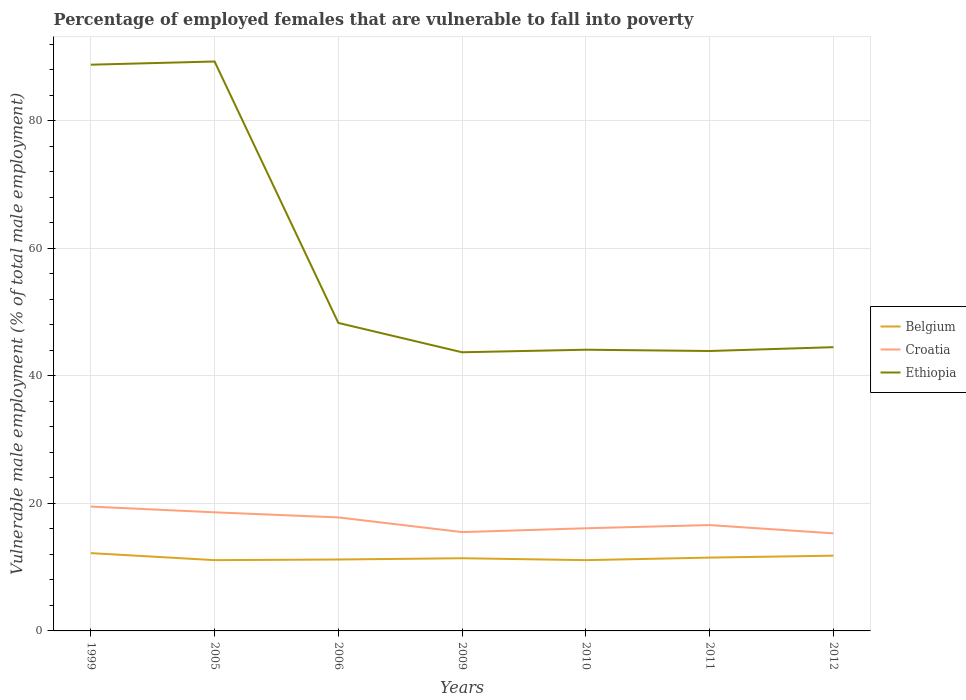Does the line corresponding to Croatia intersect with the line corresponding to Belgium?
Make the answer very short. No. Across all years, what is the maximum percentage of employed females who are vulnerable to fall into poverty in Belgium?
Your response must be concise. 11.1. What is the total percentage of employed females who are vulnerable to fall into poverty in Ethiopia in the graph?
Ensure brevity in your answer.  44.9. What is the difference between the highest and the second highest percentage of employed females who are vulnerable to fall into poverty in Ethiopia?
Offer a terse response. 45.6. What is the difference between the highest and the lowest percentage of employed females who are vulnerable to fall into poverty in Croatia?
Offer a terse response. 3. Where does the legend appear in the graph?
Ensure brevity in your answer.  Center right. How are the legend labels stacked?
Provide a short and direct response. Vertical. What is the title of the graph?
Offer a very short reply. Percentage of employed females that are vulnerable to fall into poverty. What is the label or title of the Y-axis?
Keep it short and to the point. Vulnerable male employment (% of total male employment). What is the Vulnerable male employment (% of total male employment) in Belgium in 1999?
Provide a short and direct response. 12.2. What is the Vulnerable male employment (% of total male employment) of Croatia in 1999?
Your response must be concise. 19.5. What is the Vulnerable male employment (% of total male employment) in Ethiopia in 1999?
Your answer should be very brief. 88.8. What is the Vulnerable male employment (% of total male employment) in Belgium in 2005?
Offer a very short reply. 11.1. What is the Vulnerable male employment (% of total male employment) in Croatia in 2005?
Make the answer very short. 18.6. What is the Vulnerable male employment (% of total male employment) of Ethiopia in 2005?
Keep it short and to the point. 89.3. What is the Vulnerable male employment (% of total male employment) in Belgium in 2006?
Your response must be concise. 11.2. What is the Vulnerable male employment (% of total male employment) of Croatia in 2006?
Ensure brevity in your answer.  17.8. What is the Vulnerable male employment (% of total male employment) in Ethiopia in 2006?
Give a very brief answer. 48.3. What is the Vulnerable male employment (% of total male employment) of Belgium in 2009?
Your answer should be compact. 11.4. What is the Vulnerable male employment (% of total male employment) in Ethiopia in 2009?
Provide a succinct answer. 43.7. What is the Vulnerable male employment (% of total male employment) in Belgium in 2010?
Offer a terse response. 11.1. What is the Vulnerable male employment (% of total male employment) of Croatia in 2010?
Ensure brevity in your answer.  16.1. What is the Vulnerable male employment (% of total male employment) of Ethiopia in 2010?
Ensure brevity in your answer.  44.1. What is the Vulnerable male employment (% of total male employment) of Belgium in 2011?
Make the answer very short. 11.5. What is the Vulnerable male employment (% of total male employment) of Croatia in 2011?
Keep it short and to the point. 16.6. What is the Vulnerable male employment (% of total male employment) of Ethiopia in 2011?
Offer a terse response. 43.9. What is the Vulnerable male employment (% of total male employment) of Belgium in 2012?
Your response must be concise. 11.8. What is the Vulnerable male employment (% of total male employment) in Croatia in 2012?
Offer a terse response. 15.3. What is the Vulnerable male employment (% of total male employment) of Ethiopia in 2012?
Your answer should be compact. 44.5. Across all years, what is the maximum Vulnerable male employment (% of total male employment) of Belgium?
Your answer should be compact. 12.2. Across all years, what is the maximum Vulnerable male employment (% of total male employment) of Ethiopia?
Provide a short and direct response. 89.3. Across all years, what is the minimum Vulnerable male employment (% of total male employment) of Belgium?
Provide a succinct answer. 11.1. Across all years, what is the minimum Vulnerable male employment (% of total male employment) of Croatia?
Your answer should be very brief. 15.3. Across all years, what is the minimum Vulnerable male employment (% of total male employment) of Ethiopia?
Make the answer very short. 43.7. What is the total Vulnerable male employment (% of total male employment) in Belgium in the graph?
Your answer should be compact. 80.3. What is the total Vulnerable male employment (% of total male employment) in Croatia in the graph?
Offer a terse response. 119.4. What is the total Vulnerable male employment (% of total male employment) in Ethiopia in the graph?
Keep it short and to the point. 402.6. What is the difference between the Vulnerable male employment (% of total male employment) of Belgium in 1999 and that in 2005?
Your answer should be compact. 1.1. What is the difference between the Vulnerable male employment (% of total male employment) in Croatia in 1999 and that in 2005?
Provide a succinct answer. 0.9. What is the difference between the Vulnerable male employment (% of total male employment) in Ethiopia in 1999 and that in 2005?
Keep it short and to the point. -0.5. What is the difference between the Vulnerable male employment (% of total male employment) in Belgium in 1999 and that in 2006?
Provide a succinct answer. 1. What is the difference between the Vulnerable male employment (% of total male employment) of Croatia in 1999 and that in 2006?
Offer a very short reply. 1.7. What is the difference between the Vulnerable male employment (% of total male employment) in Ethiopia in 1999 and that in 2006?
Provide a short and direct response. 40.5. What is the difference between the Vulnerable male employment (% of total male employment) of Belgium in 1999 and that in 2009?
Provide a short and direct response. 0.8. What is the difference between the Vulnerable male employment (% of total male employment) in Ethiopia in 1999 and that in 2009?
Offer a very short reply. 45.1. What is the difference between the Vulnerable male employment (% of total male employment) of Ethiopia in 1999 and that in 2010?
Give a very brief answer. 44.7. What is the difference between the Vulnerable male employment (% of total male employment) in Ethiopia in 1999 and that in 2011?
Provide a short and direct response. 44.9. What is the difference between the Vulnerable male employment (% of total male employment) of Belgium in 1999 and that in 2012?
Ensure brevity in your answer.  0.4. What is the difference between the Vulnerable male employment (% of total male employment) of Croatia in 1999 and that in 2012?
Offer a terse response. 4.2. What is the difference between the Vulnerable male employment (% of total male employment) in Ethiopia in 1999 and that in 2012?
Offer a terse response. 44.3. What is the difference between the Vulnerable male employment (% of total male employment) of Ethiopia in 2005 and that in 2009?
Offer a terse response. 45.6. What is the difference between the Vulnerable male employment (% of total male employment) of Belgium in 2005 and that in 2010?
Make the answer very short. 0. What is the difference between the Vulnerable male employment (% of total male employment) in Croatia in 2005 and that in 2010?
Provide a succinct answer. 2.5. What is the difference between the Vulnerable male employment (% of total male employment) of Ethiopia in 2005 and that in 2010?
Your answer should be compact. 45.2. What is the difference between the Vulnerable male employment (% of total male employment) of Belgium in 2005 and that in 2011?
Make the answer very short. -0.4. What is the difference between the Vulnerable male employment (% of total male employment) in Croatia in 2005 and that in 2011?
Provide a succinct answer. 2. What is the difference between the Vulnerable male employment (% of total male employment) of Ethiopia in 2005 and that in 2011?
Provide a succinct answer. 45.4. What is the difference between the Vulnerable male employment (% of total male employment) of Ethiopia in 2005 and that in 2012?
Provide a short and direct response. 44.8. What is the difference between the Vulnerable male employment (% of total male employment) in Ethiopia in 2006 and that in 2009?
Give a very brief answer. 4.6. What is the difference between the Vulnerable male employment (% of total male employment) in Ethiopia in 2006 and that in 2010?
Your response must be concise. 4.2. What is the difference between the Vulnerable male employment (% of total male employment) in Croatia in 2006 and that in 2011?
Provide a short and direct response. 1.2. What is the difference between the Vulnerable male employment (% of total male employment) of Ethiopia in 2006 and that in 2011?
Give a very brief answer. 4.4. What is the difference between the Vulnerable male employment (% of total male employment) in Belgium in 2006 and that in 2012?
Provide a succinct answer. -0.6. What is the difference between the Vulnerable male employment (% of total male employment) of Croatia in 2006 and that in 2012?
Offer a very short reply. 2.5. What is the difference between the Vulnerable male employment (% of total male employment) of Ethiopia in 2009 and that in 2010?
Offer a very short reply. -0.4. What is the difference between the Vulnerable male employment (% of total male employment) in Ethiopia in 2009 and that in 2011?
Keep it short and to the point. -0.2. What is the difference between the Vulnerable male employment (% of total male employment) in Ethiopia in 2009 and that in 2012?
Ensure brevity in your answer.  -0.8. What is the difference between the Vulnerable male employment (% of total male employment) of Belgium in 2010 and that in 2011?
Keep it short and to the point. -0.4. What is the difference between the Vulnerable male employment (% of total male employment) in Croatia in 2010 and that in 2011?
Keep it short and to the point. -0.5. What is the difference between the Vulnerable male employment (% of total male employment) of Belgium in 2010 and that in 2012?
Provide a succinct answer. -0.7. What is the difference between the Vulnerable male employment (% of total male employment) of Croatia in 2010 and that in 2012?
Offer a terse response. 0.8. What is the difference between the Vulnerable male employment (% of total male employment) in Ethiopia in 2010 and that in 2012?
Offer a very short reply. -0.4. What is the difference between the Vulnerable male employment (% of total male employment) in Croatia in 2011 and that in 2012?
Make the answer very short. 1.3. What is the difference between the Vulnerable male employment (% of total male employment) of Belgium in 1999 and the Vulnerable male employment (% of total male employment) of Ethiopia in 2005?
Keep it short and to the point. -77.1. What is the difference between the Vulnerable male employment (% of total male employment) of Croatia in 1999 and the Vulnerable male employment (% of total male employment) of Ethiopia in 2005?
Provide a succinct answer. -69.8. What is the difference between the Vulnerable male employment (% of total male employment) of Belgium in 1999 and the Vulnerable male employment (% of total male employment) of Ethiopia in 2006?
Provide a short and direct response. -36.1. What is the difference between the Vulnerable male employment (% of total male employment) of Croatia in 1999 and the Vulnerable male employment (% of total male employment) of Ethiopia in 2006?
Make the answer very short. -28.8. What is the difference between the Vulnerable male employment (% of total male employment) in Belgium in 1999 and the Vulnerable male employment (% of total male employment) in Croatia in 2009?
Offer a terse response. -3.3. What is the difference between the Vulnerable male employment (% of total male employment) of Belgium in 1999 and the Vulnerable male employment (% of total male employment) of Ethiopia in 2009?
Keep it short and to the point. -31.5. What is the difference between the Vulnerable male employment (% of total male employment) of Croatia in 1999 and the Vulnerable male employment (% of total male employment) of Ethiopia in 2009?
Ensure brevity in your answer.  -24.2. What is the difference between the Vulnerable male employment (% of total male employment) in Belgium in 1999 and the Vulnerable male employment (% of total male employment) in Croatia in 2010?
Your answer should be compact. -3.9. What is the difference between the Vulnerable male employment (% of total male employment) of Belgium in 1999 and the Vulnerable male employment (% of total male employment) of Ethiopia in 2010?
Ensure brevity in your answer.  -31.9. What is the difference between the Vulnerable male employment (% of total male employment) in Croatia in 1999 and the Vulnerable male employment (% of total male employment) in Ethiopia in 2010?
Offer a terse response. -24.6. What is the difference between the Vulnerable male employment (% of total male employment) in Belgium in 1999 and the Vulnerable male employment (% of total male employment) in Croatia in 2011?
Your answer should be compact. -4.4. What is the difference between the Vulnerable male employment (% of total male employment) in Belgium in 1999 and the Vulnerable male employment (% of total male employment) in Ethiopia in 2011?
Give a very brief answer. -31.7. What is the difference between the Vulnerable male employment (% of total male employment) in Croatia in 1999 and the Vulnerable male employment (% of total male employment) in Ethiopia in 2011?
Your response must be concise. -24.4. What is the difference between the Vulnerable male employment (% of total male employment) of Belgium in 1999 and the Vulnerable male employment (% of total male employment) of Ethiopia in 2012?
Give a very brief answer. -32.3. What is the difference between the Vulnerable male employment (% of total male employment) in Belgium in 2005 and the Vulnerable male employment (% of total male employment) in Ethiopia in 2006?
Make the answer very short. -37.2. What is the difference between the Vulnerable male employment (% of total male employment) of Croatia in 2005 and the Vulnerable male employment (% of total male employment) of Ethiopia in 2006?
Give a very brief answer. -29.7. What is the difference between the Vulnerable male employment (% of total male employment) in Belgium in 2005 and the Vulnerable male employment (% of total male employment) in Croatia in 2009?
Offer a very short reply. -4.4. What is the difference between the Vulnerable male employment (% of total male employment) in Belgium in 2005 and the Vulnerable male employment (% of total male employment) in Ethiopia in 2009?
Give a very brief answer. -32.6. What is the difference between the Vulnerable male employment (% of total male employment) of Croatia in 2005 and the Vulnerable male employment (% of total male employment) of Ethiopia in 2009?
Provide a short and direct response. -25.1. What is the difference between the Vulnerable male employment (% of total male employment) of Belgium in 2005 and the Vulnerable male employment (% of total male employment) of Ethiopia in 2010?
Ensure brevity in your answer.  -33. What is the difference between the Vulnerable male employment (% of total male employment) of Croatia in 2005 and the Vulnerable male employment (% of total male employment) of Ethiopia in 2010?
Your answer should be compact. -25.5. What is the difference between the Vulnerable male employment (% of total male employment) of Belgium in 2005 and the Vulnerable male employment (% of total male employment) of Croatia in 2011?
Offer a very short reply. -5.5. What is the difference between the Vulnerable male employment (% of total male employment) of Belgium in 2005 and the Vulnerable male employment (% of total male employment) of Ethiopia in 2011?
Give a very brief answer. -32.8. What is the difference between the Vulnerable male employment (% of total male employment) in Croatia in 2005 and the Vulnerable male employment (% of total male employment) in Ethiopia in 2011?
Provide a succinct answer. -25.3. What is the difference between the Vulnerable male employment (% of total male employment) in Belgium in 2005 and the Vulnerable male employment (% of total male employment) in Ethiopia in 2012?
Your answer should be compact. -33.4. What is the difference between the Vulnerable male employment (% of total male employment) of Croatia in 2005 and the Vulnerable male employment (% of total male employment) of Ethiopia in 2012?
Provide a succinct answer. -25.9. What is the difference between the Vulnerable male employment (% of total male employment) in Belgium in 2006 and the Vulnerable male employment (% of total male employment) in Ethiopia in 2009?
Make the answer very short. -32.5. What is the difference between the Vulnerable male employment (% of total male employment) of Croatia in 2006 and the Vulnerable male employment (% of total male employment) of Ethiopia in 2009?
Keep it short and to the point. -25.9. What is the difference between the Vulnerable male employment (% of total male employment) of Belgium in 2006 and the Vulnerable male employment (% of total male employment) of Ethiopia in 2010?
Your response must be concise. -32.9. What is the difference between the Vulnerable male employment (% of total male employment) in Croatia in 2006 and the Vulnerable male employment (% of total male employment) in Ethiopia in 2010?
Ensure brevity in your answer.  -26.3. What is the difference between the Vulnerable male employment (% of total male employment) in Belgium in 2006 and the Vulnerable male employment (% of total male employment) in Ethiopia in 2011?
Keep it short and to the point. -32.7. What is the difference between the Vulnerable male employment (% of total male employment) in Croatia in 2006 and the Vulnerable male employment (% of total male employment) in Ethiopia in 2011?
Your answer should be very brief. -26.1. What is the difference between the Vulnerable male employment (% of total male employment) in Belgium in 2006 and the Vulnerable male employment (% of total male employment) in Croatia in 2012?
Your response must be concise. -4.1. What is the difference between the Vulnerable male employment (% of total male employment) in Belgium in 2006 and the Vulnerable male employment (% of total male employment) in Ethiopia in 2012?
Provide a succinct answer. -33.3. What is the difference between the Vulnerable male employment (% of total male employment) in Croatia in 2006 and the Vulnerable male employment (% of total male employment) in Ethiopia in 2012?
Make the answer very short. -26.7. What is the difference between the Vulnerable male employment (% of total male employment) of Belgium in 2009 and the Vulnerable male employment (% of total male employment) of Croatia in 2010?
Provide a succinct answer. -4.7. What is the difference between the Vulnerable male employment (% of total male employment) of Belgium in 2009 and the Vulnerable male employment (% of total male employment) of Ethiopia in 2010?
Keep it short and to the point. -32.7. What is the difference between the Vulnerable male employment (% of total male employment) in Croatia in 2009 and the Vulnerable male employment (% of total male employment) in Ethiopia in 2010?
Your answer should be very brief. -28.6. What is the difference between the Vulnerable male employment (% of total male employment) in Belgium in 2009 and the Vulnerable male employment (% of total male employment) in Croatia in 2011?
Make the answer very short. -5.2. What is the difference between the Vulnerable male employment (% of total male employment) of Belgium in 2009 and the Vulnerable male employment (% of total male employment) of Ethiopia in 2011?
Ensure brevity in your answer.  -32.5. What is the difference between the Vulnerable male employment (% of total male employment) in Croatia in 2009 and the Vulnerable male employment (% of total male employment) in Ethiopia in 2011?
Your answer should be very brief. -28.4. What is the difference between the Vulnerable male employment (% of total male employment) of Belgium in 2009 and the Vulnerable male employment (% of total male employment) of Croatia in 2012?
Provide a succinct answer. -3.9. What is the difference between the Vulnerable male employment (% of total male employment) in Belgium in 2009 and the Vulnerable male employment (% of total male employment) in Ethiopia in 2012?
Offer a very short reply. -33.1. What is the difference between the Vulnerable male employment (% of total male employment) in Croatia in 2009 and the Vulnerable male employment (% of total male employment) in Ethiopia in 2012?
Keep it short and to the point. -29. What is the difference between the Vulnerable male employment (% of total male employment) in Belgium in 2010 and the Vulnerable male employment (% of total male employment) in Croatia in 2011?
Keep it short and to the point. -5.5. What is the difference between the Vulnerable male employment (% of total male employment) in Belgium in 2010 and the Vulnerable male employment (% of total male employment) in Ethiopia in 2011?
Keep it short and to the point. -32.8. What is the difference between the Vulnerable male employment (% of total male employment) of Croatia in 2010 and the Vulnerable male employment (% of total male employment) of Ethiopia in 2011?
Offer a very short reply. -27.8. What is the difference between the Vulnerable male employment (% of total male employment) in Belgium in 2010 and the Vulnerable male employment (% of total male employment) in Ethiopia in 2012?
Your answer should be compact. -33.4. What is the difference between the Vulnerable male employment (% of total male employment) in Croatia in 2010 and the Vulnerable male employment (% of total male employment) in Ethiopia in 2012?
Ensure brevity in your answer.  -28.4. What is the difference between the Vulnerable male employment (% of total male employment) in Belgium in 2011 and the Vulnerable male employment (% of total male employment) in Ethiopia in 2012?
Make the answer very short. -33. What is the difference between the Vulnerable male employment (% of total male employment) in Croatia in 2011 and the Vulnerable male employment (% of total male employment) in Ethiopia in 2012?
Keep it short and to the point. -27.9. What is the average Vulnerable male employment (% of total male employment) in Belgium per year?
Offer a terse response. 11.47. What is the average Vulnerable male employment (% of total male employment) in Croatia per year?
Offer a very short reply. 17.06. What is the average Vulnerable male employment (% of total male employment) in Ethiopia per year?
Offer a terse response. 57.51. In the year 1999, what is the difference between the Vulnerable male employment (% of total male employment) of Belgium and Vulnerable male employment (% of total male employment) of Ethiopia?
Ensure brevity in your answer.  -76.6. In the year 1999, what is the difference between the Vulnerable male employment (% of total male employment) of Croatia and Vulnerable male employment (% of total male employment) of Ethiopia?
Offer a terse response. -69.3. In the year 2005, what is the difference between the Vulnerable male employment (% of total male employment) in Belgium and Vulnerable male employment (% of total male employment) in Ethiopia?
Keep it short and to the point. -78.2. In the year 2005, what is the difference between the Vulnerable male employment (% of total male employment) of Croatia and Vulnerable male employment (% of total male employment) of Ethiopia?
Keep it short and to the point. -70.7. In the year 2006, what is the difference between the Vulnerable male employment (% of total male employment) in Belgium and Vulnerable male employment (% of total male employment) in Croatia?
Provide a succinct answer. -6.6. In the year 2006, what is the difference between the Vulnerable male employment (% of total male employment) of Belgium and Vulnerable male employment (% of total male employment) of Ethiopia?
Your answer should be very brief. -37.1. In the year 2006, what is the difference between the Vulnerable male employment (% of total male employment) of Croatia and Vulnerable male employment (% of total male employment) of Ethiopia?
Your response must be concise. -30.5. In the year 2009, what is the difference between the Vulnerable male employment (% of total male employment) of Belgium and Vulnerable male employment (% of total male employment) of Croatia?
Give a very brief answer. -4.1. In the year 2009, what is the difference between the Vulnerable male employment (% of total male employment) of Belgium and Vulnerable male employment (% of total male employment) of Ethiopia?
Give a very brief answer. -32.3. In the year 2009, what is the difference between the Vulnerable male employment (% of total male employment) in Croatia and Vulnerable male employment (% of total male employment) in Ethiopia?
Keep it short and to the point. -28.2. In the year 2010, what is the difference between the Vulnerable male employment (% of total male employment) of Belgium and Vulnerable male employment (% of total male employment) of Ethiopia?
Keep it short and to the point. -33. In the year 2010, what is the difference between the Vulnerable male employment (% of total male employment) of Croatia and Vulnerable male employment (% of total male employment) of Ethiopia?
Your response must be concise. -28. In the year 2011, what is the difference between the Vulnerable male employment (% of total male employment) in Belgium and Vulnerable male employment (% of total male employment) in Ethiopia?
Your response must be concise. -32.4. In the year 2011, what is the difference between the Vulnerable male employment (% of total male employment) in Croatia and Vulnerable male employment (% of total male employment) in Ethiopia?
Ensure brevity in your answer.  -27.3. In the year 2012, what is the difference between the Vulnerable male employment (% of total male employment) of Belgium and Vulnerable male employment (% of total male employment) of Croatia?
Offer a terse response. -3.5. In the year 2012, what is the difference between the Vulnerable male employment (% of total male employment) in Belgium and Vulnerable male employment (% of total male employment) in Ethiopia?
Give a very brief answer. -32.7. In the year 2012, what is the difference between the Vulnerable male employment (% of total male employment) of Croatia and Vulnerable male employment (% of total male employment) of Ethiopia?
Offer a terse response. -29.2. What is the ratio of the Vulnerable male employment (% of total male employment) in Belgium in 1999 to that in 2005?
Your answer should be very brief. 1.1. What is the ratio of the Vulnerable male employment (% of total male employment) in Croatia in 1999 to that in 2005?
Provide a short and direct response. 1.05. What is the ratio of the Vulnerable male employment (% of total male employment) of Belgium in 1999 to that in 2006?
Keep it short and to the point. 1.09. What is the ratio of the Vulnerable male employment (% of total male employment) in Croatia in 1999 to that in 2006?
Your answer should be very brief. 1.1. What is the ratio of the Vulnerable male employment (% of total male employment) in Ethiopia in 1999 to that in 2006?
Your response must be concise. 1.84. What is the ratio of the Vulnerable male employment (% of total male employment) in Belgium in 1999 to that in 2009?
Your response must be concise. 1.07. What is the ratio of the Vulnerable male employment (% of total male employment) in Croatia in 1999 to that in 2009?
Give a very brief answer. 1.26. What is the ratio of the Vulnerable male employment (% of total male employment) in Ethiopia in 1999 to that in 2009?
Ensure brevity in your answer.  2.03. What is the ratio of the Vulnerable male employment (% of total male employment) of Belgium in 1999 to that in 2010?
Make the answer very short. 1.1. What is the ratio of the Vulnerable male employment (% of total male employment) in Croatia in 1999 to that in 2010?
Your response must be concise. 1.21. What is the ratio of the Vulnerable male employment (% of total male employment) of Ethiopia in 1999 to that in 2010?
Your answer should be very brief. 2.01. What is the ratio of the Vulnerable male employment (% of total male employment) in Belgium in 1999 to that in 2011?
Your response must be concise. 1.06. What is the ratio of the Vulnerable male employment (% of total male employment) in Croatia in 1999 to that in 2011?
Offer a very short reply. 1.17. What is the ratio of the Vulnerable male employment (% of total male employment) in Ethiopia in 1999 to that in 2011?
Give a very brief answer. 2.02. What is the ratio of the Vulnerable male employment (% of total male employment) in Belgium in 1999 to that in 2012?
Offer a very short reply. 1.03. What is the ratio of the Vulnerable male employment (% of total male employment) of Croatia in 1999 to that in 2012?
Keep it short and to the point. 1.27. What is the ratio of the Vulnerable male employment (% of total male employment) in Ethiopia in 1999 to that in 2012?
Your answer should be compact. 2. What is the ratio of the Vulnerable male employment (% of total male employment) in Croatia in 2005 to that in 2006?
Keep it short and to the point. 1.04. What is the ratio of the Vulnerable male employment (% of total male employment) in Ethiopia in 2005 to that in 2006?
Make the answer very short. 1.85. What is the ratio of the Vulnerable male employment (% of total male employment) in Belgium in 2005 to that in 2009?
Make the answer very short. 0.97. What is the ratio of the Vulnerable male employment (% of total male employment) in Croatia in 2005 to that in 2009?
Give a very brief answer. 1.2. What is the ratio of the Vulnerable male employment (% of total male employment) in Ethiopia in 2005 to that in 2009?
Keep it short and to the point. 2.04. What is the ratio of the Vulnerable male employment (% of total male employment) in Croatia in 2005 to that in 2010?
Provide a short and direct response. 1.16. What is the ratio of the Vulnerable male employment (% of total male employment) in Ethiopia in 2005 to that in 2010?
Provide a succinct answer. 2.02. What is the ratio of the Vulnerable male employment (% of total male employment) in Belgium in 2005 to that in 2011?
Your answer should be compact. 0.97. What is the ratio of the Vulnerable male employment (% of total male employment) of Croatia in 2005 to that in 2011?
Make the answer very short. 1.12. What is the ratio of the Vulnerable male employment (% of total male employment) in Ethiopia in 2005 to that in 2011?
Provide a succinct answer. 2.03. What is the ratio of the Vulnerable male employment (% of total male employment) of Belgium in 2005 to that in 2012?
Keep it short and to the point. 0.94. What is the ratio of the Vulnerable male employment (% of total male employment) of Croatia in 2005 to that in 2012?
Offer a terse response. 1.22. What is the ratio of the Vulnerable male employment (% of total male employment) of Ethiopia in 2005 to that in 2012?
Make the answer very short. 2.01. What is the ratio of the Vulnerable male employment (% of total male employment) of Belgium in 2006 to that in 2009?
Ensure brevity in your answer.  0.98. What is the ratio of the Vulnerable male employment (% of total male employment) in Croatia in 2006 to that in 2009?
Keep it short and to the point. 1.15. What is the ratio of the Vulnerable male employment (% of total male employment) of Ethiopia in 2006 to that in 2009?
Ensure brevity in your answer.  1.11. What is the ratio of the Vulnerable male employment (% of total male employment) in Croatia in 2006 to that in 2010?
Your answer should be very brief. 1.11. What is the ratio of the Vulnerable male employment (% of total male employment) in Ethiopia in 2006 to that in 2010?
Your answer should be very brief. 1.1. What is the ratio of the Vulnerable male employment (% of total male employment) in Belgium in 2006 to that in 2011?
Ensure brevity in your answer.  0.97. What is the ratio of the Vulnerable male employment (% of total male employment) in Croatia in 2006 to that in 2011?
Your response must be concise. 1.07. What is the ratio of the Vulnerable male employment (% of total male employment) in Ethiopia in 2006 to that in 2011?
Make the answer very short. 1.1. What is the ratio of the Vulnerable male employment (% of total male employment) in Belgium in 2006 to that in 2012?
Ensure brevity in your answer.  0.95. What is the ratio of the Vulnerable male employment (% of total male employment) of Croatia in 2006 to that in 2012?
Offer a terse response. 1.16. What is the ratio of the Vulnerable male employment (% of total male employment) of Ethiopia in 2006 to that in 2012?
Your answer should be compact. 1.09. What is the ratio of the Vulnerable male employment (% of total male employment) of Croatia in 2009 to that in 2010?
Provide a short and direct response. 0.96. What is the ratio of the Vulnerable male employment (% of total male employment) in Ethiopia in 2009 to that in 2010?
Offer a terse response. 0.99. What is the ratio of the Vulnerable male employment (% of total male employment) of Belgium in 2009 to that in 2011?
Offer a very short reply. 0.99. What is the ratio of the Vulnerable male employment (% of total male employment) in Croatia in 2009 to that in 2011?
Your answer should be compact. 0.93. What is the ratio of the Vulnerable male employment (% of total male employment) in Ethiopia in 2009 to that in 2011?
Give a very brief answer. 1. What is the ratio of the Vulnerable male employment (% of total male employment) in Belgium in 2009 to that in 2012?
Give a very brief answer. 0.97. What is the ratio of the Vulnerable male employment (% of total male employment) of Croatia in 2009 to that in 2012?
Keep it short and to the point. 1.01. What is the ratio of the Vulnerable male employment (% of total male employment) of Ethiopia in 2009 to that in 2012?
Your answer should be compact. 0.98. What is the ratio of the Vulnerable male employment (% of total male employment) of Belgium in 2010 to that in 2011?
Provide a succinct answer. 0.97. What is the ratio of the Vulnerable male employment (% of total male employment) of Croatia in 2010 to that in 2011?
Your response must be concise. 0.97. What is the ratio of the Vulnerable male employment (% of total male employment) in Belgium in 2010 to that in 2012?
Your answer should be very brief. 0.94. What is the ratio of the Vulnerable male employment (% of total male employment) in Croatia in 2010 to that in 2012?
Ensure brevity in your answer.  1.05. What is the ratio of the Vulnerable male employment (% of total male employment) of Belgium in 2011 to that in 2012?
Keep it short and to the point. 0.97. What is the ratio of the Vulnerable male employment (% of total male employment) in Croatia in 2011 to that in 2012?
Offer a terse response. 1.08. What is the ratio of the Vulnerable male employment (% of total male employment) of Ethiopia in 2011 to that in 2012?
Your answer should be compact. 0.99. What is the difference between the highest and the second highest Vulnerable male employment (% of total male employment) in Belgium?
Offer a terse response. 0.4. What is the difference between the highest and the lowest Vulnerable male employment (% of total male employment) of Belgium?
Offer a terse response. 1.1. What is the difference between the highest and the lowest Vulnerable male employment (% of total male employment) in Croatia?
Your answer should be compact. 4.2. What is the difference between the highest and the lowest Vulnerable male employment (% of total male employment) in Ethiopia?
Your answer should be compact. 45.6. 